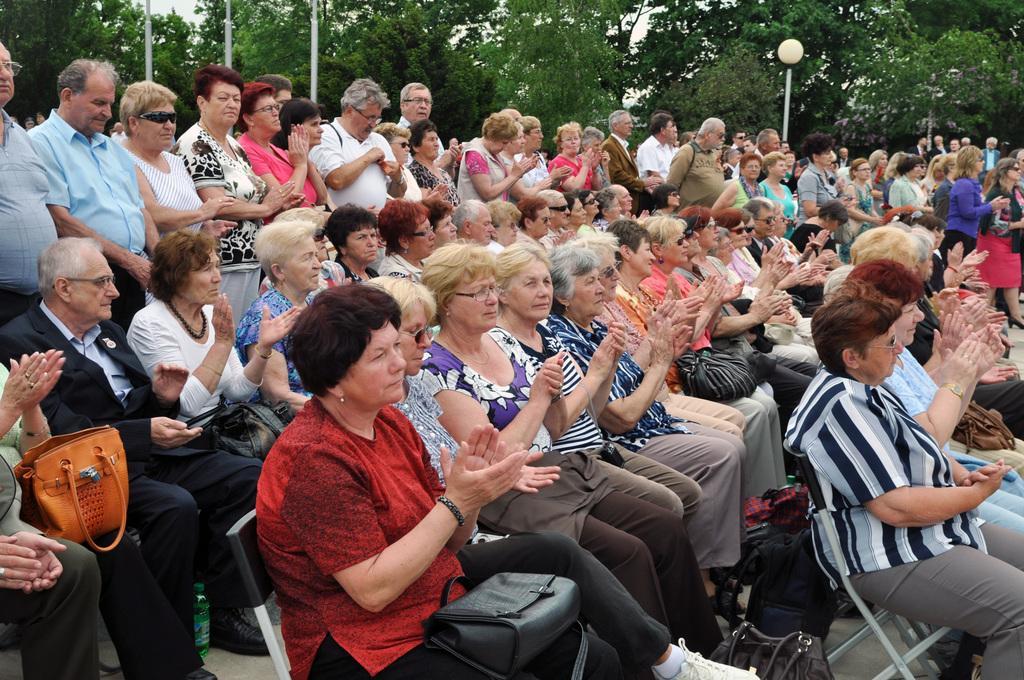Please provide a concise description of this image. These group of people are sitting on chairs. Backside of this group of people, persons are standing and most of the persons are clapping hands. Front on this woman there is a handbag. Far there are number of trees. In-front of the trees there are light poles. 